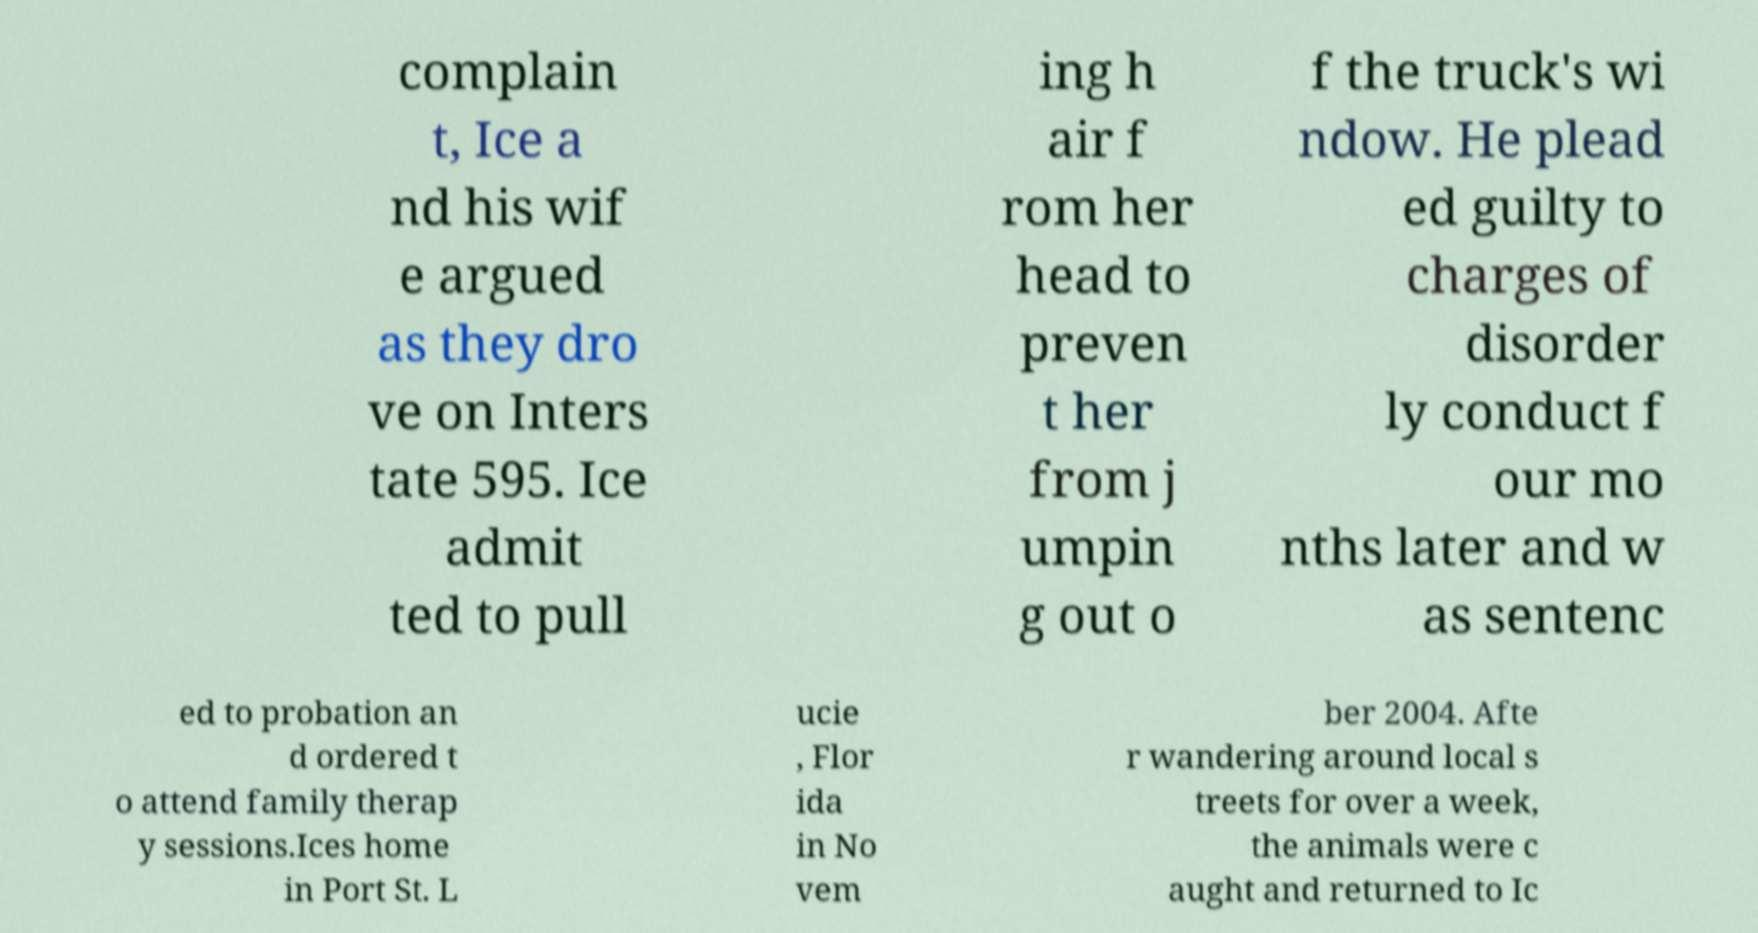Please read and relay the text visible in this image. What does it say? complain t, Ice a nd his wif e argued as they dro ve on Inters tate 595. Ice admit ted to pull ing h air f rom her head to preven t her from j umpin g out o f the truck's wi ndow. He plead ed guilty to charges of disorder ly conduct f our mo nths later and w as sentenc ed to probation an d ordered t o attend family therap y sessions.Ices home in Port St. L ucie , Flor ida in No vem ber 2004. Afte r wandering around local s treets for over a week, the animals were c aught and returned to Ic 